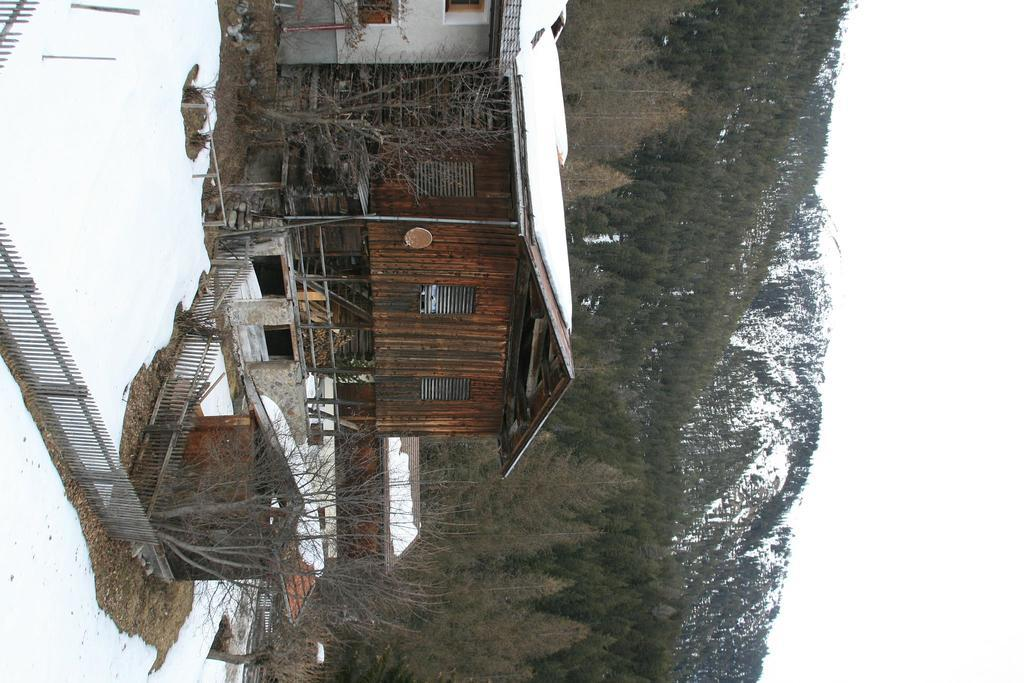What is the main structure in the center of the image? There is a building with windows in the center of the image. What type of barrier is present in the image? There is a metal fence in the image. What type of vegetation can be seen in the image? There is a group of trees in the image. What can be seen in the distance in the image? There are mountains visible in the background of the image. What is visible above the mountains in the image? The sky is visible in the background of the image. Who is the creator of the mountains in the image? The mountains are a natural formation and not created by a specific person, so there is no creator for the mountains in the image. 